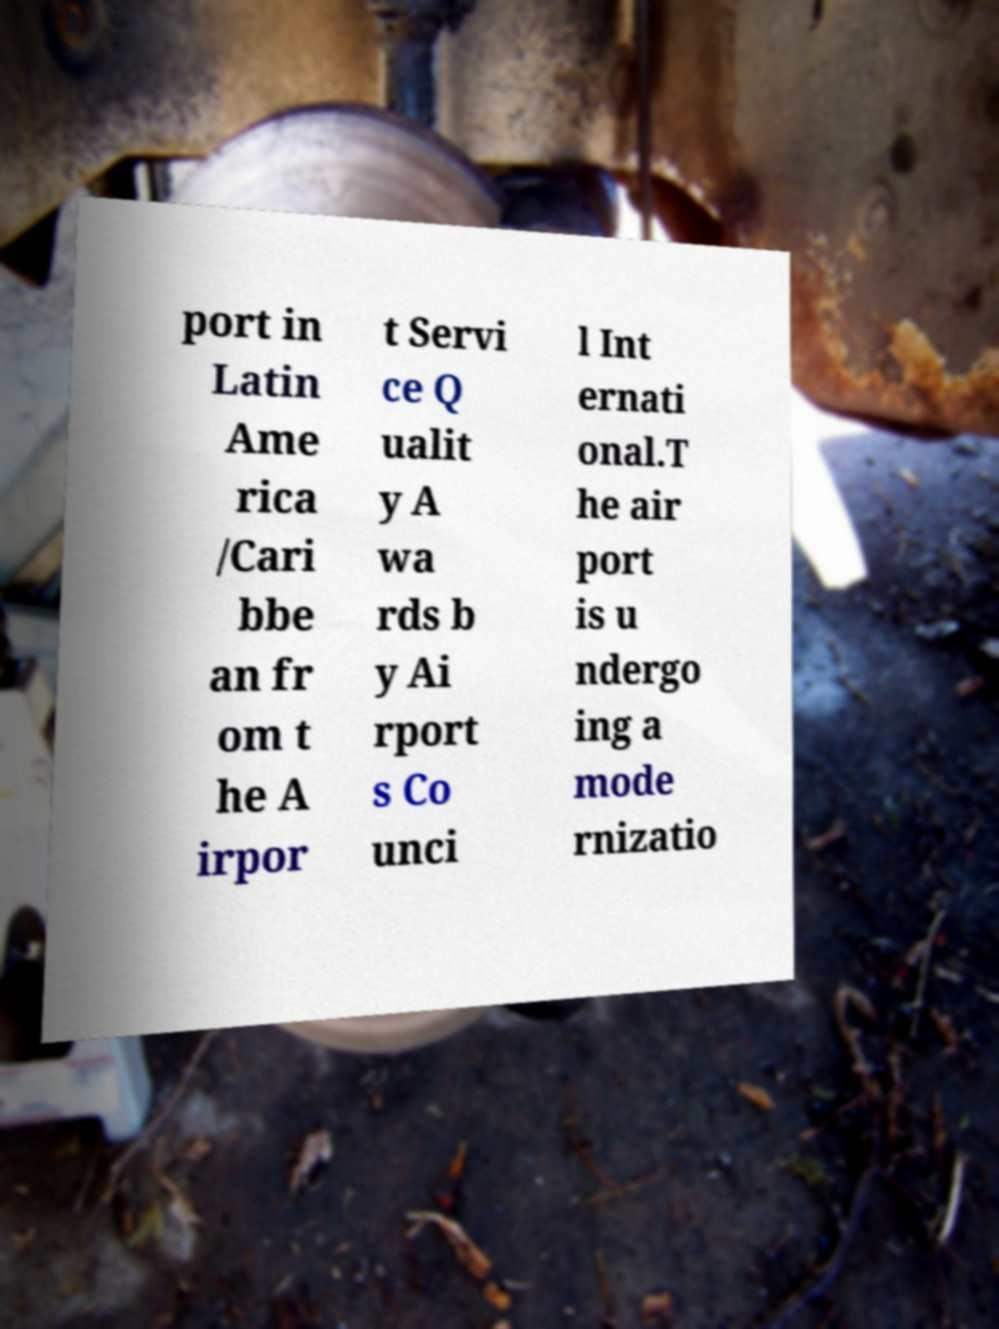What messages or text are displayed in this image? I need them in a readable, typed format. port in Latin Ame rica /Cari bbe an fr om t he A irpor t Servi ce Q ualit y A wa rds b y Ai rport s Co unci l Int ernati onal.T he air port is u ndergo ing a mode rnizatio 